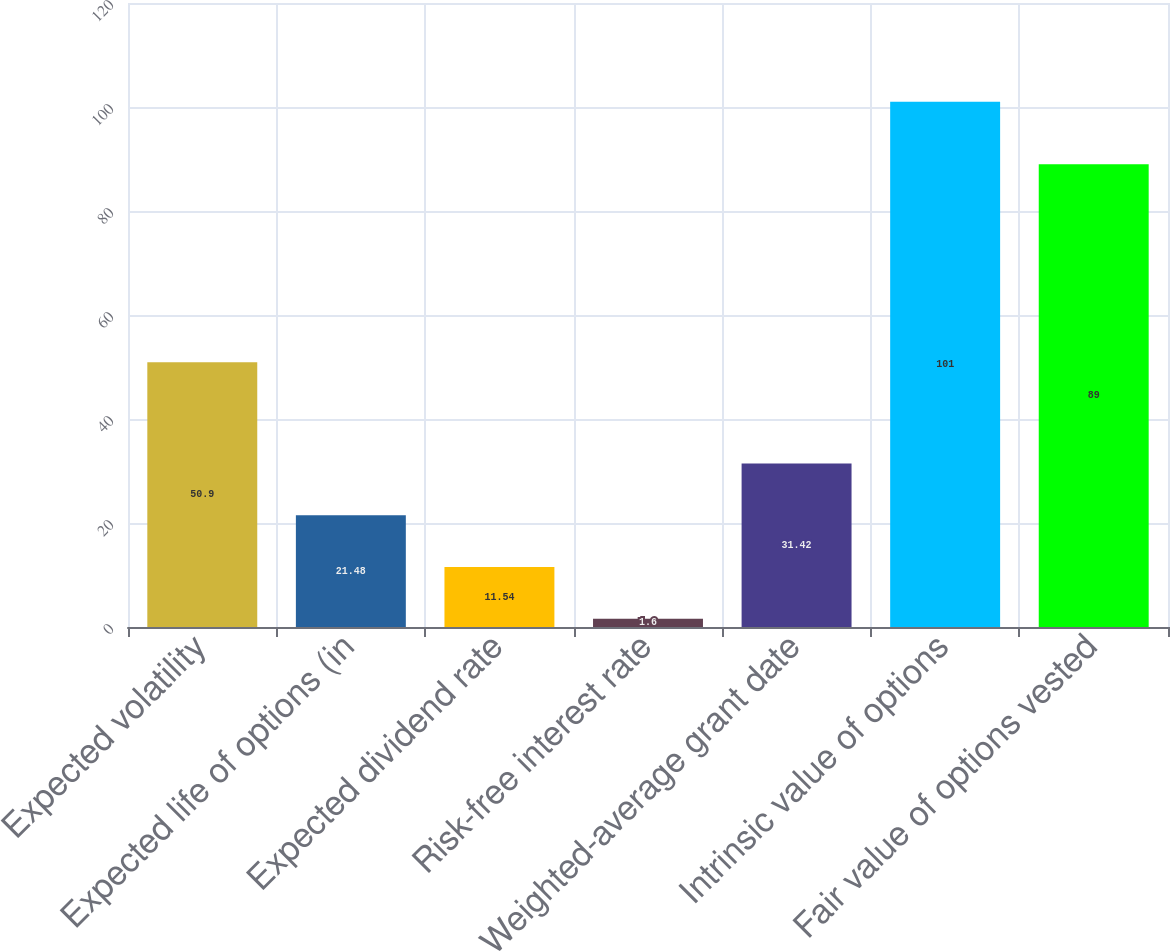Convert chart. <chart><loc_0><loc_0><loc_500><loc_500><bar_chart><fcel>Expected volatility<fcel>Expected life of options (in<fcel>Expected dividend rate<fcel>Risk-free interest rate<fcel>Weighted-average grant date<fcel>Intrinsic value of options<fcel>Fair value of options vested<nl><fcel>50.9<fcel>21.48<fcel>11.54<fcel>1.6<fcel>31.42<fcel>101<fcel>89<nl></chart> 